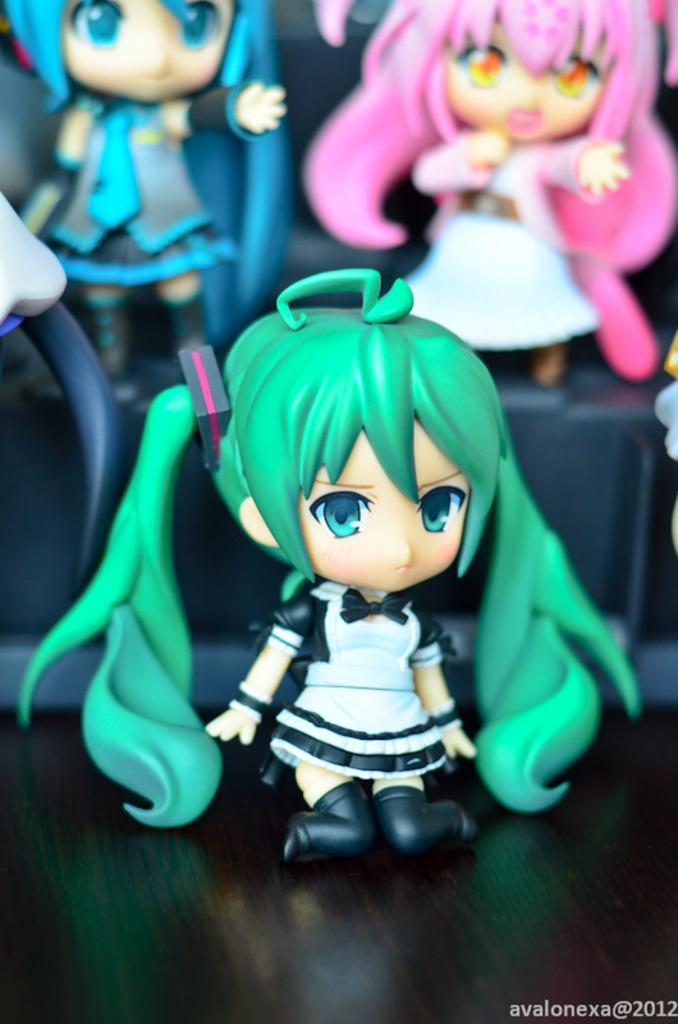What type of objects can be seen in the image? There are toys in the image. What is the color of the surface in the image? The surface in the image is black. Is there any additional information or marking on the image? Yes, there is a watermark at the bottom of the image. Can you tell me how many chess pieces are on the black surface in the image? There is no indication of chess pieces in the image; it features toys on a black surface. Is there a volcano visible in the image? No, there is no volcano present in the image. 